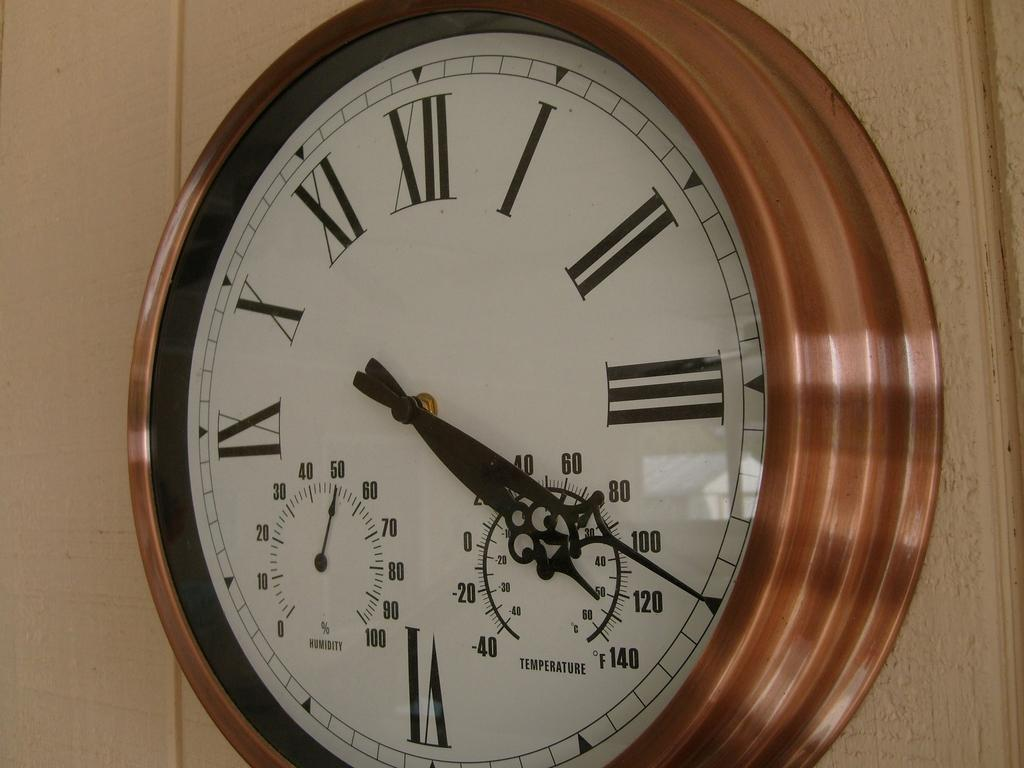<image>
Share a concise interpretation of the image provided. An ornate wall clock tells the time as 4:20 